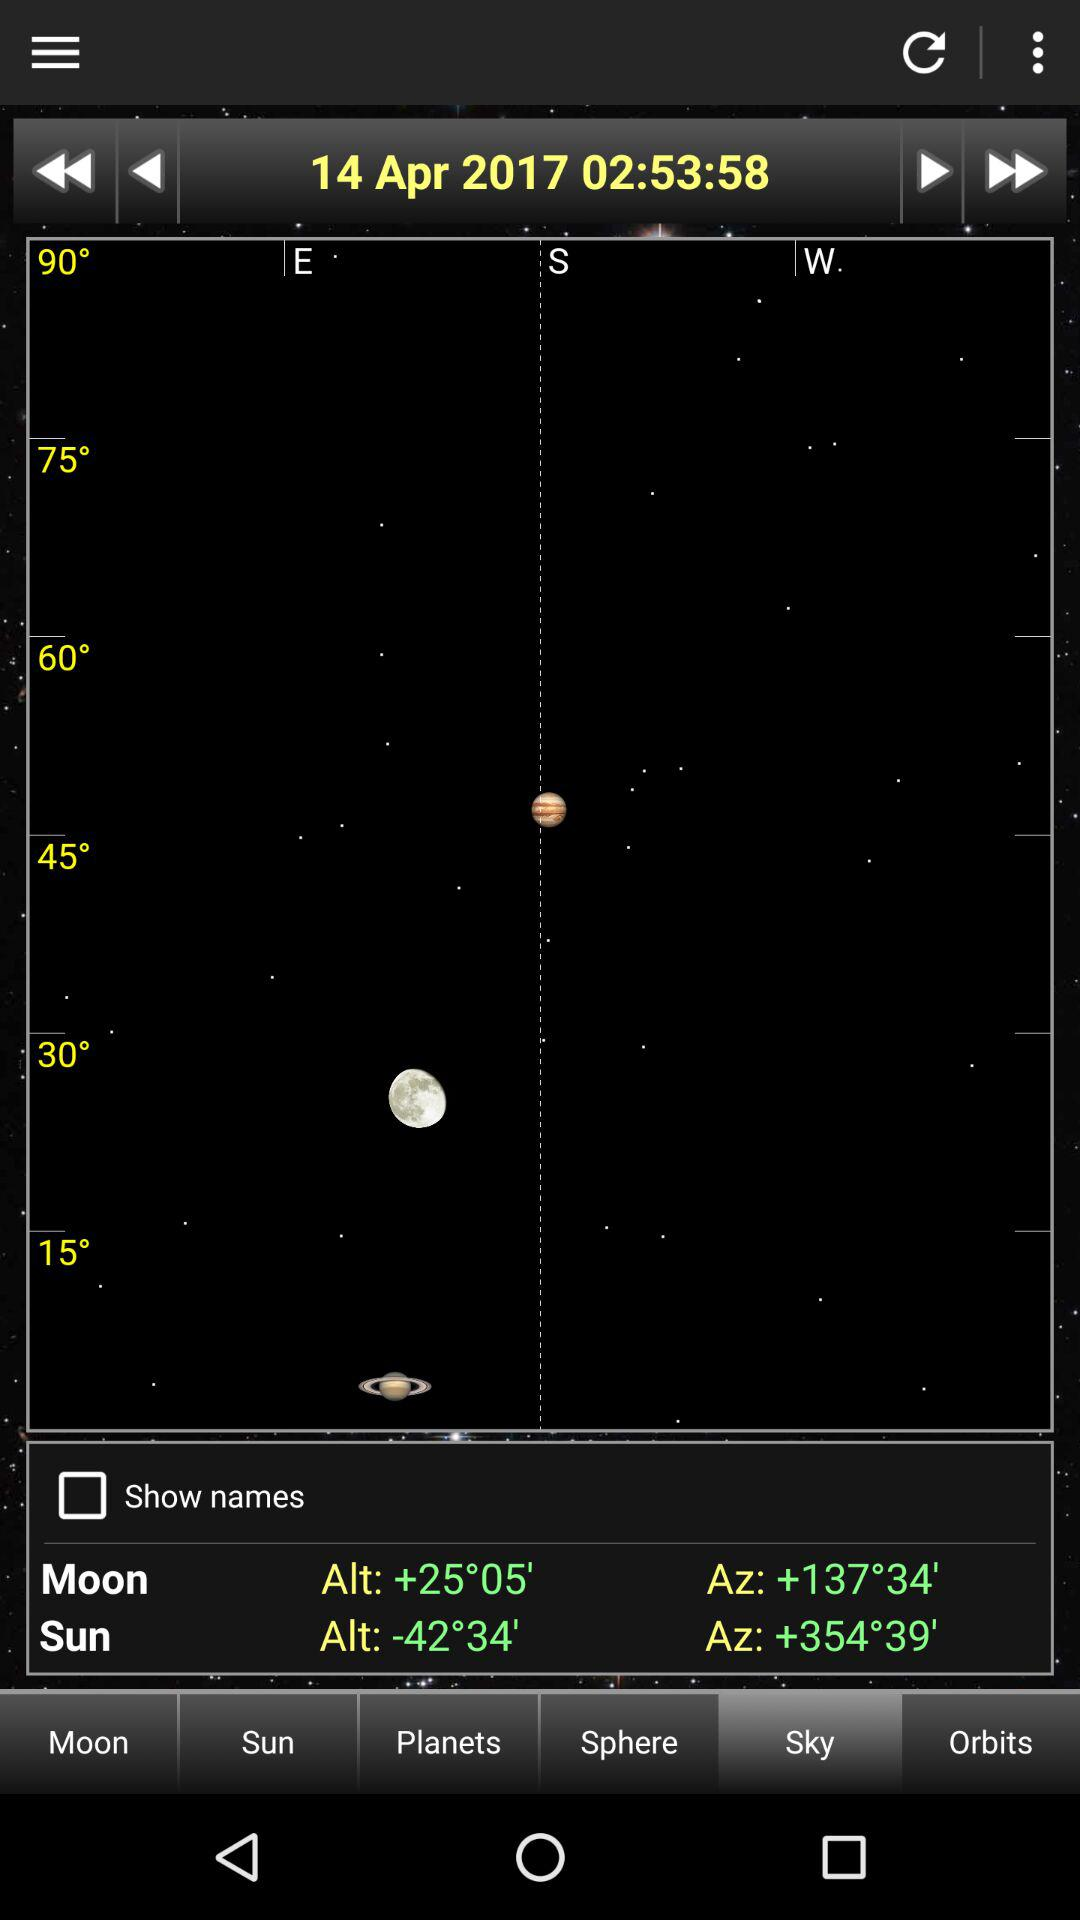What is the moon's Az value? The moon's Az value is +137°34'. 